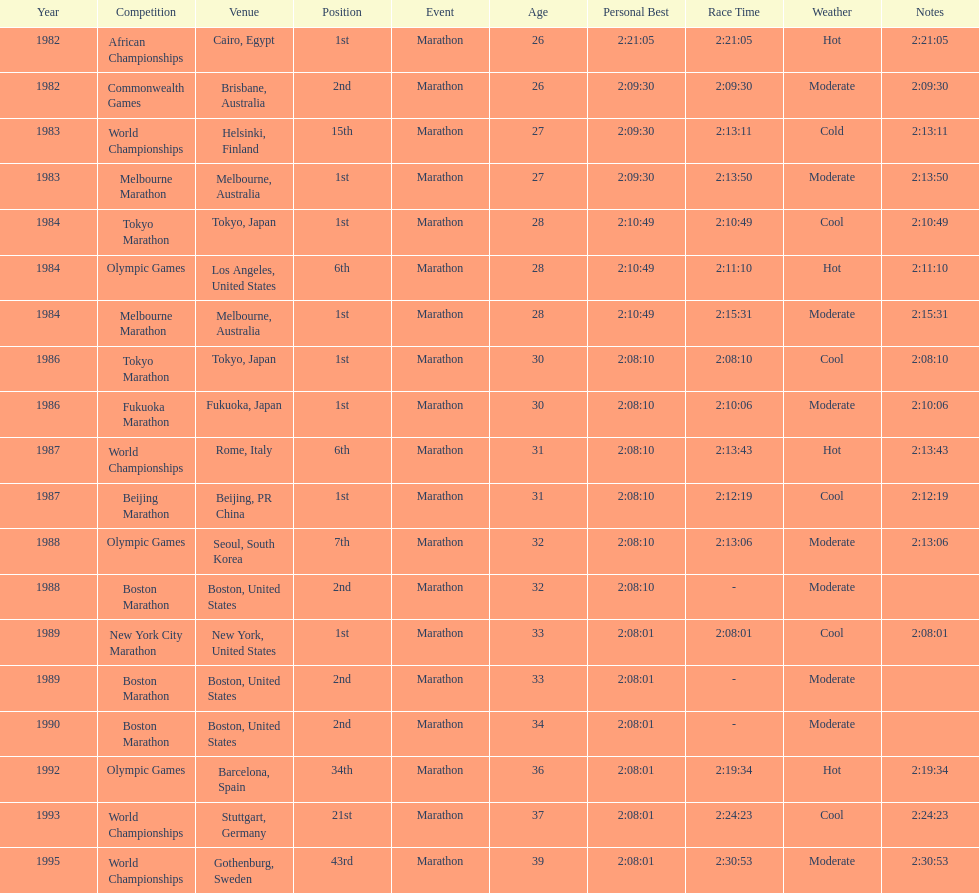In what year did the runner participate in the most marathons? 1984. 